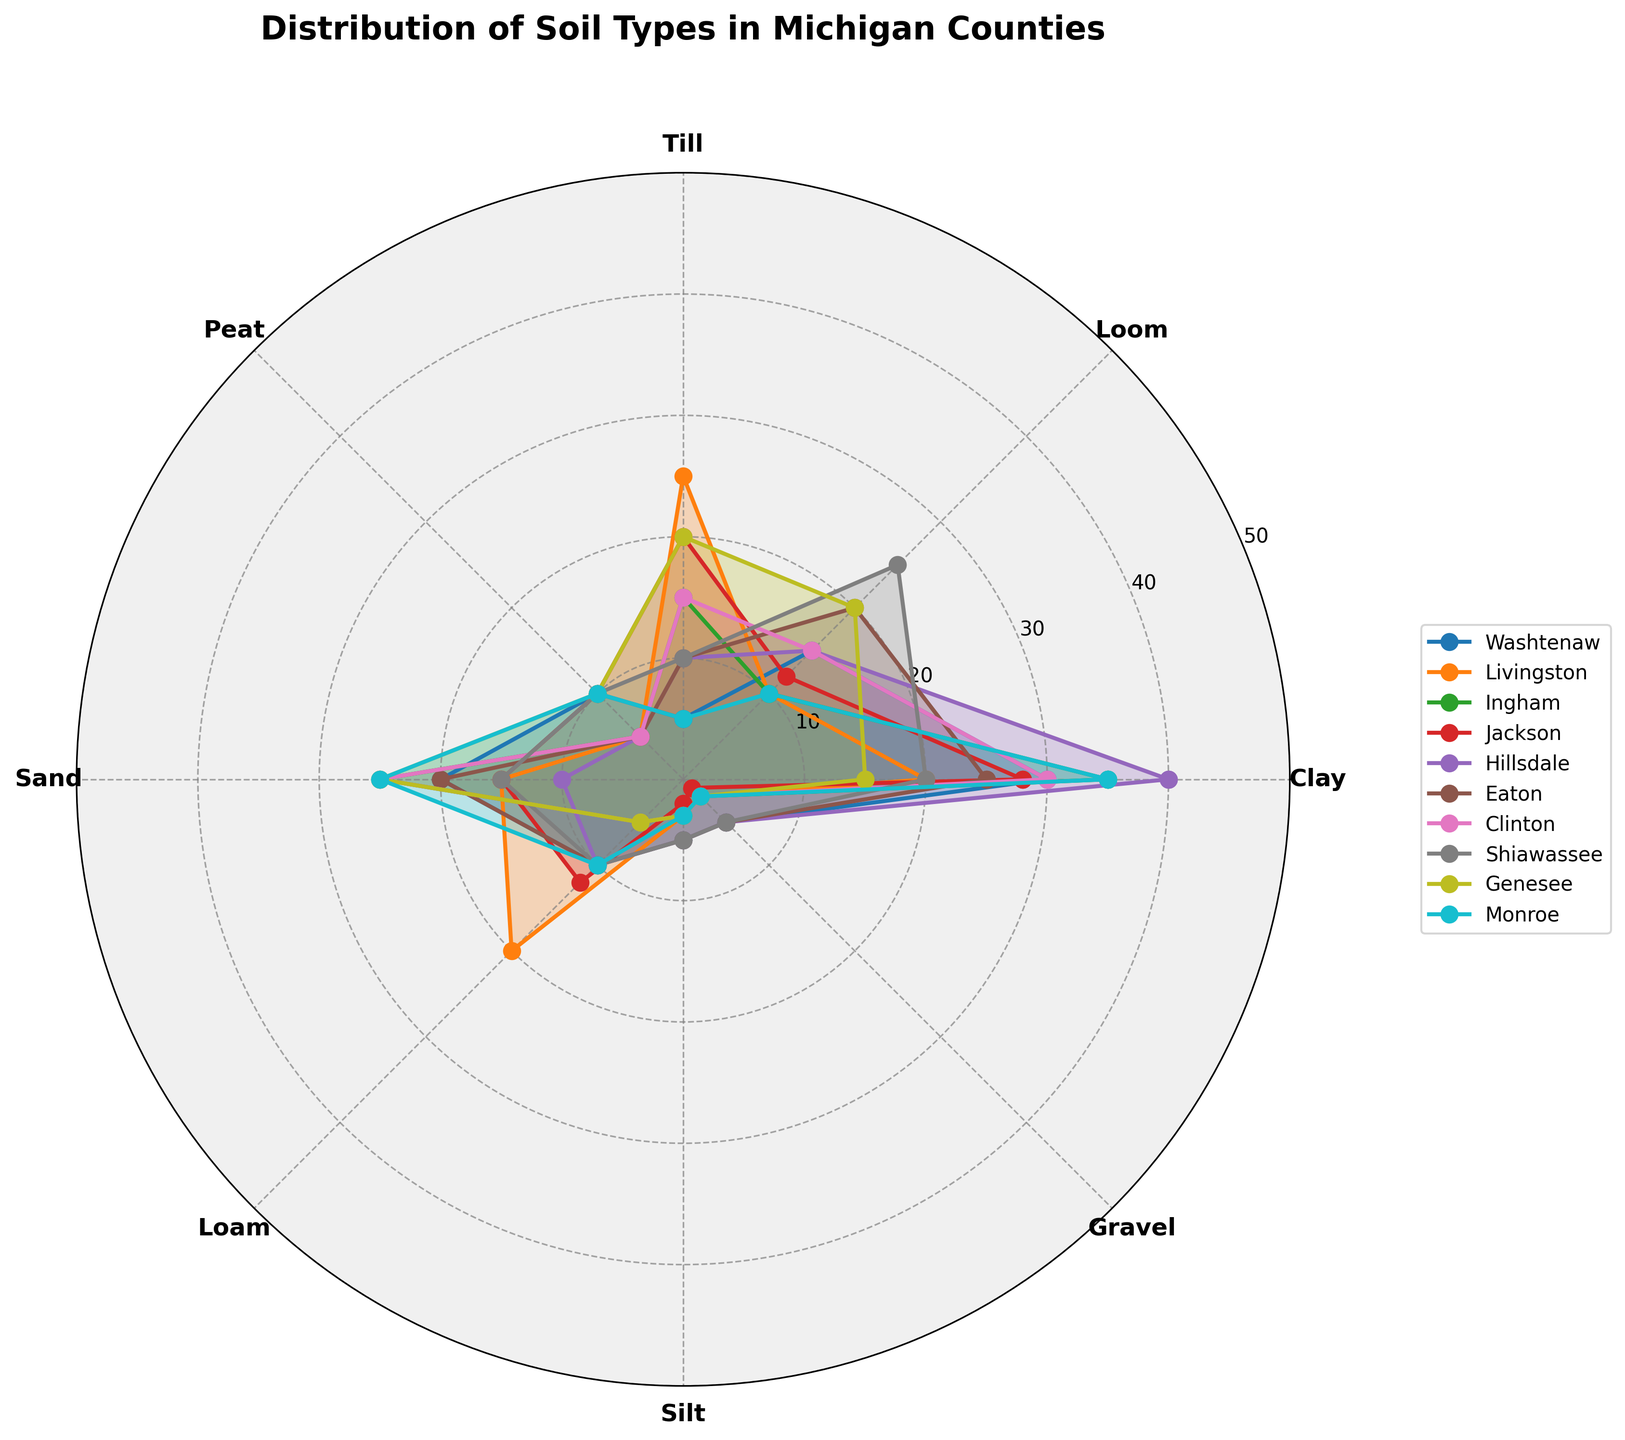What's the title of the figure? The title of the figure is usually displayed prominently at the top. In this case, it is "Distribution of Soil Types in Michigan Counties".
Answer: Distribution of Soil Types in Michigan Counties Which county has the highest percentage of Sand? Look at the Sand section for each county's polar plot. The one reaching the highest value is the one with the most Sand. In this case, both Ingham and Clinton have sections reaching 25%.
Answer: Ingham and Clinton What is the average percentage of Clay across all counties? Sum the percentages of Clay for all counties and divide by the number of counties (10). Calculation: (30+20+35+28+40+25+30+20+15+35) / 10 = 27.8%
Answer: 27.8% Which two soil types have equal percentages in Hillsdale county? Identify if there are two lines corresponding to different soil types that reach the same value in Hillsdale. Both Clay and Loom are at 15%.
Answer: Clay and Loom Is the percentage of Peat higher in Monroe or Livingston? Refer to the Peat section on the polar plot for both counties and compare the values. Monroe has 10% and Livingston has 5%.
Answer: Monroe Which county has the most diverse range of soil types? The most diverse range can be identified by looking at the plot where the values for soil types vary widely. Shiawassee shows a wide range of soil types from 3% to 25%.
Answer: Shiawassee Which counties have the least percentage of Gravel? Look at the Gravel section for each county. Jackson has only 1%, which is the least among all counties.
Answer: Jackson What percentage of Loom does Washtenaw county have? Locate the Loom section for Washtenaw and find the corresponding value, which is 15%.
Answer: 15% How does the percentage of Silt in Ingham compare to Genesee? Compare the height of the Silt sections in the polar plots for Ingham and Genesee. Both have a value of 3%.
Answer: Equal (3%) How much higher is the percentage of Clay in Hillsdale compared to Monroe? Find the Clay values for Hillsdale (40%) and Monroe (35%) and calculate the difference: 40% - 35% = 5%.
Answer: 5% 